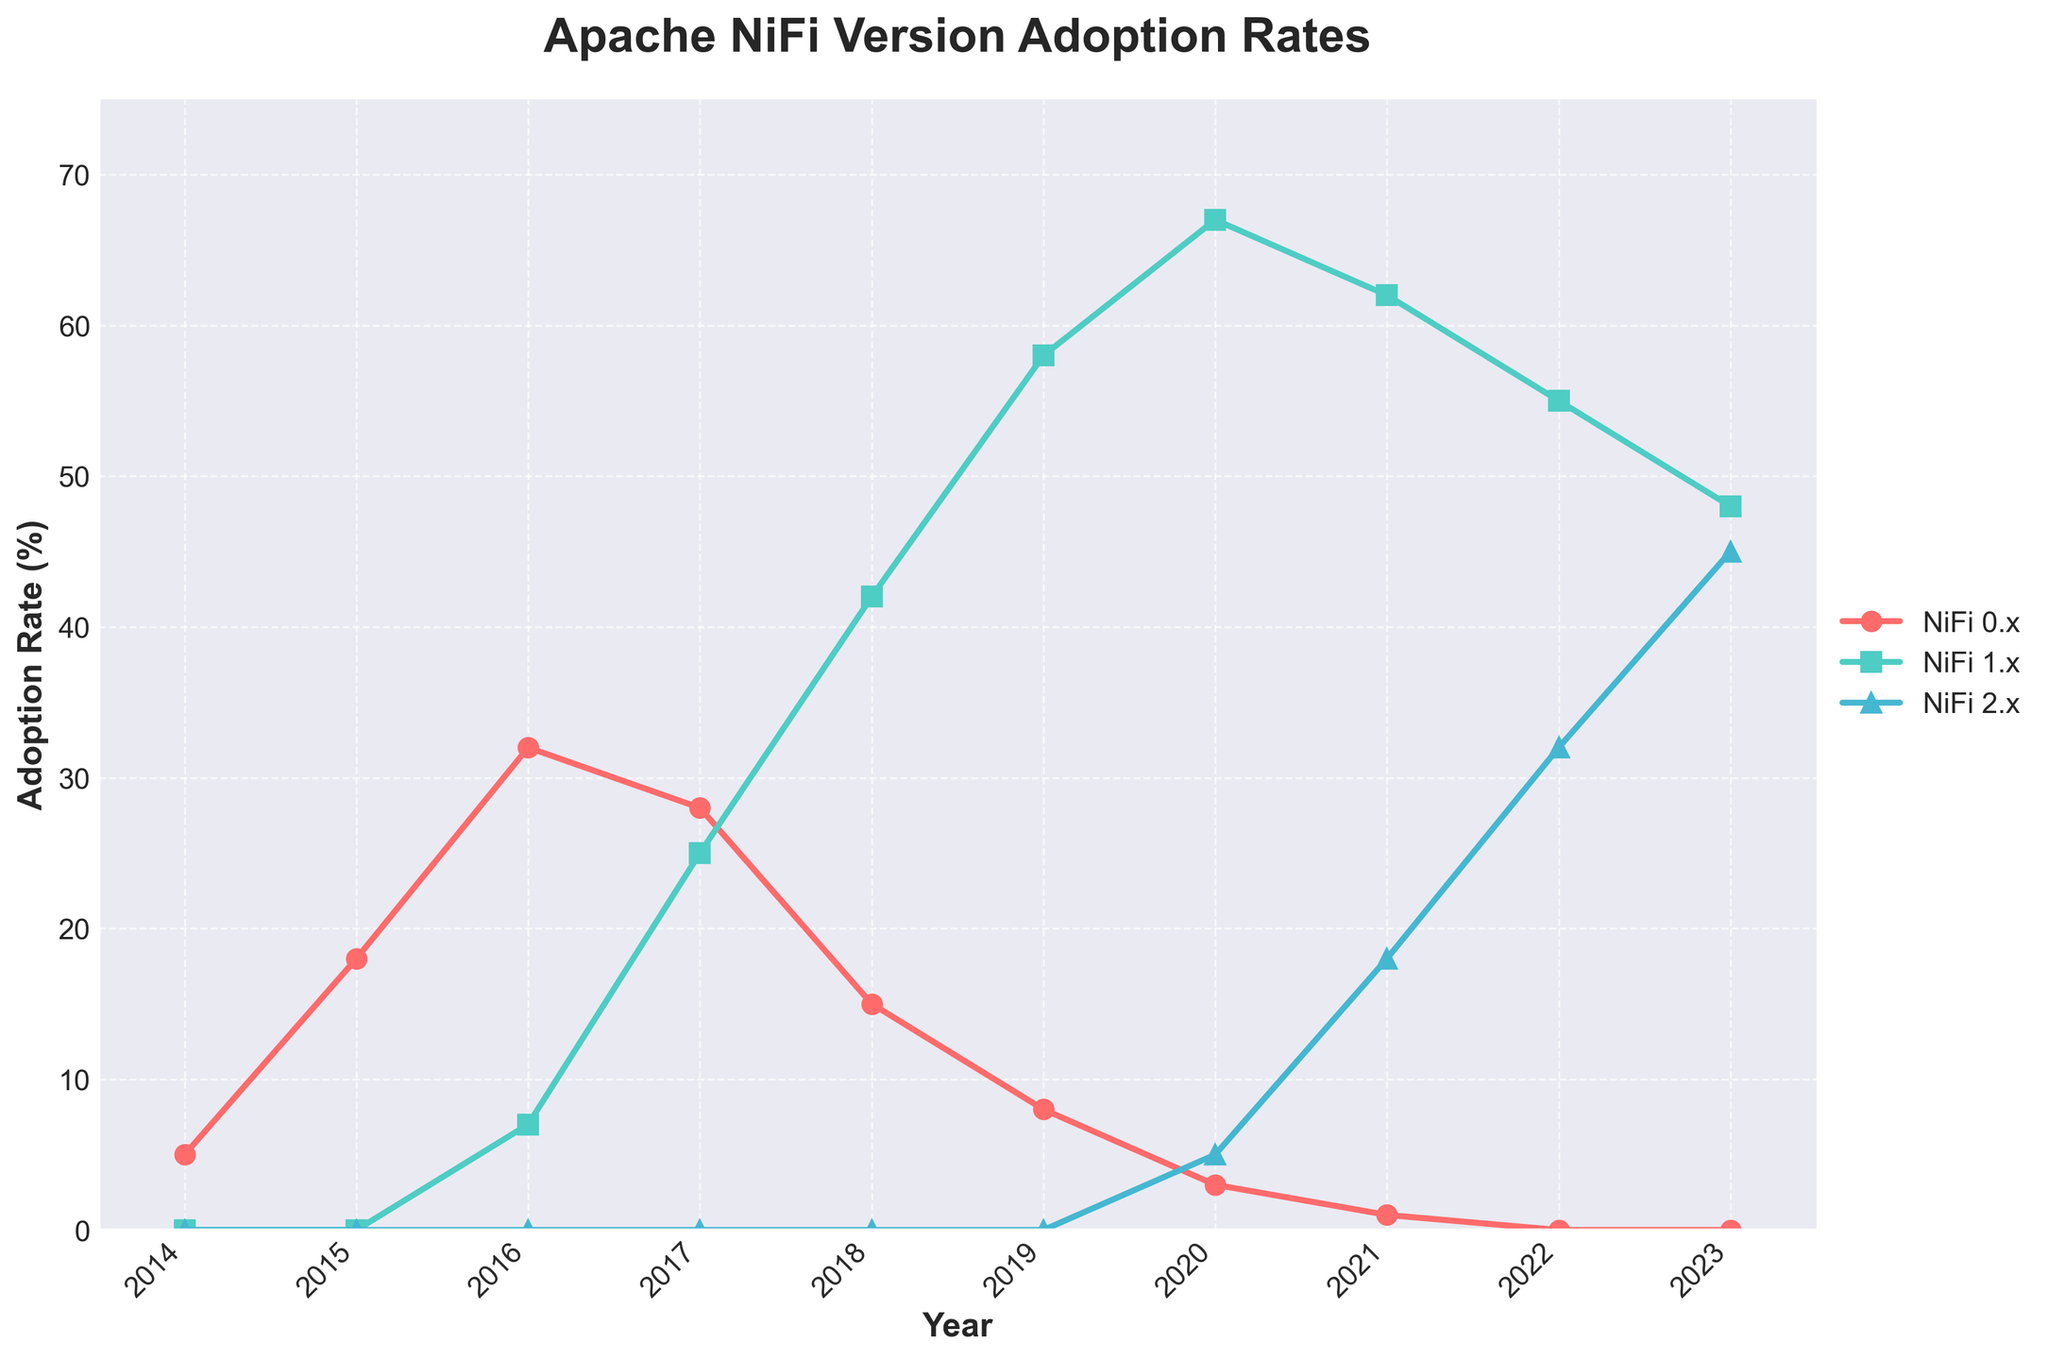Which year saw the highest adoption rate for NiFi 1.x? Look for the highest point of the NiFi 1.x line and the corresponding year on the x-axis. The highest point on the NiFi 1.x line is in 2020.
Answer: 2020 When did NiFi 2.x first appear in the adoption data? Identify the first year that has a non-zero value for the NiFi 2.x line. NiFi 2.x first appears in 2020 with an adoption rate of 5%.
Answer: 2020 What is the difference in adoption rates of NiFi 1.x between 2017 and 2023? Check the adoption rates of NiFi 1.x in 2017 and 2023. In 2017, it is 25%, and in 2023, it is 48%. The difference is 48 - 25 = 23%.
Answer: 23% Was NiFi 0.x ever adopted more than NiFi 1.x in any year? Compare the highest value of NiFi 0.x with the corresponding values of NiFi 1.x each year. In 2015, NiFi 0.x adoption was 18% while NiFi 1.x had 0%. Hence, NiFi 0.x had a higher adoption rate in 2015.
Answer: Yes In which year did all three versions (0.x, 1.x, and 2.x) have non-zero adoption rates? Look for the year where all three lines have non-zero values. In 2020, NiFi 0.x had 3%, NiFi 1.x had 67%, and NiFi 2.x had 5%.
Answer: 2020 What is the average adoption rate of NiFi 0.x from 2014 to 2023? Sum the adoption rates of NiFi 0.x from 2014 to 2023 and divide by the number of years. The rates are 5, 18, 32, 28, 15, 8, 3, 1, 0, 0. Sum = 110. Average = 110 / 10 = 11%.
Answer: 11% Compare the adoption rate of NiFi 1.x and NiFi 2.x in 2022. Check the values at 2022 for both lines. NiFi 1.x is at 55%, while NiFi 2.x is at 32%. NiFi 1.x has a higher adoption rate.
Answer: NiFi 1.x > NiFi 2.x What color represents the NiFi 2.x adoption rate line? Identify the color of the line corresponding to NiFi 2.x. The color of the NiFi 2.x line is blue.
Answer: Blue How much did the adoption rate of NiFi 1.x change between 2018 and 2020? Find the adoption rates in 2018 and 2020. In 2018, it is 42%, and in 2020, it is 67%. The change is 67 - 42 = 25%.
Answer: 25% Which version had the highest adoption rate in 2023? Check the values for each version in 2023. NiFi 2.x had the highest with 45%.
Answer: NiFi 2.x 